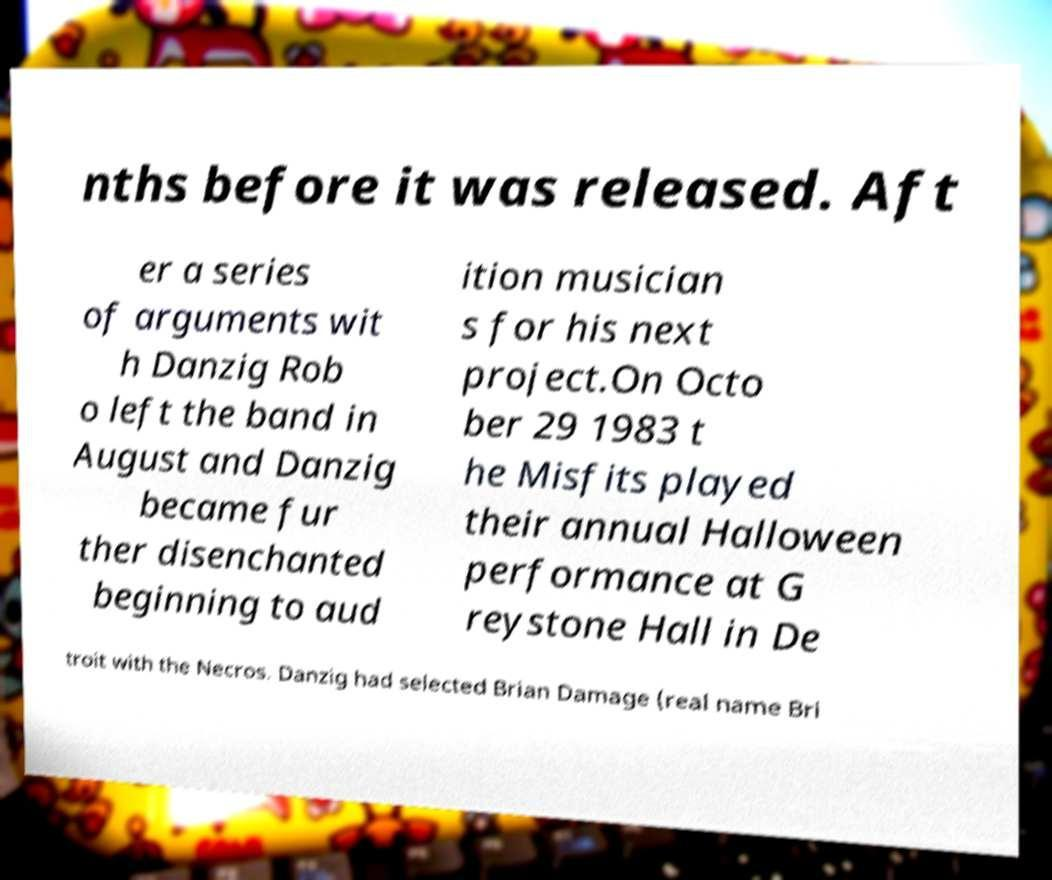Could you assist in decoding the text presented in this image and type it out clearly? nths before it was released. Aft er a series of arguments wit h Danzig Rob o left the band in August and Danzig became fur ther disenchanted beginning to aud ition musician s for his next project.On Octo ber 29 1983 t he Misfits played their annual Halloween performance at G reystone Hall in De troit with the Necros. Danzig had selected Brian Damage (real name Bri 